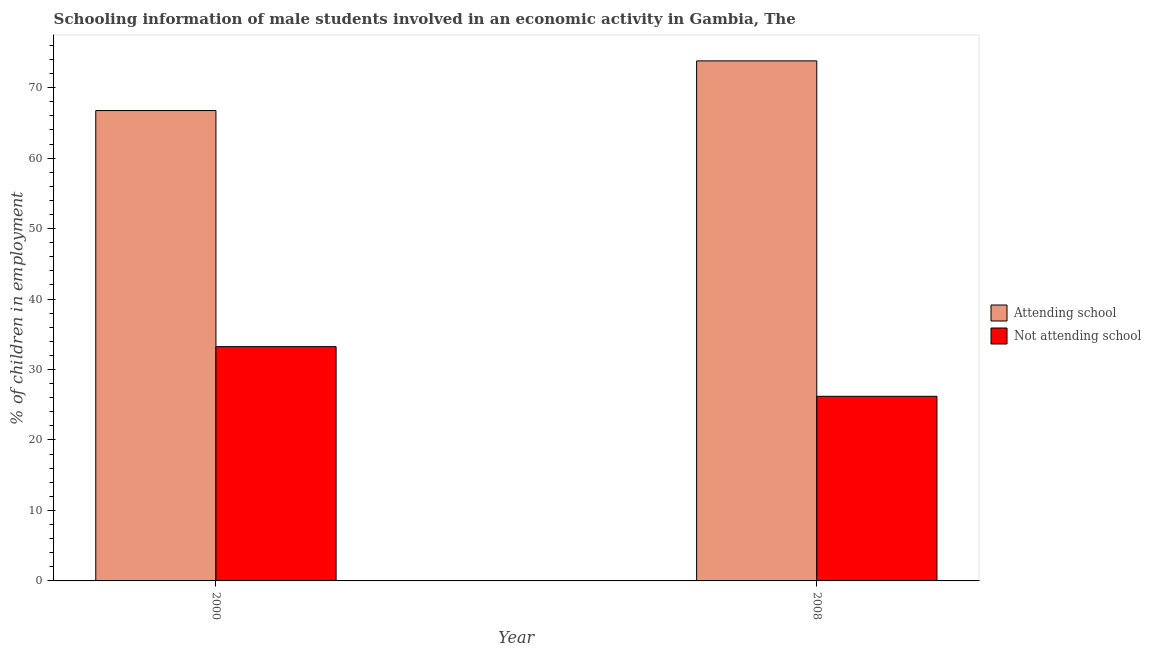How many different coloured bars are there?
Provide a short and direct response. 2. Are the number of bars per tick equal to the number of legend labels?
Your response must be concise. Yes. Are the number of bars on each tick of the X-axis equal?
Your answer should be compact. Yes. How many bars are there on the 1st tick from the left?
Make the answer very short. 2. What is the label of the 2nd group of bars from the left?
Give a very brief answer. 2008. What is the percentage of employed males who are not attending school in 2008?
Your answer should be compact. 26.2. Across all years, what is the maximum percentage of employed males who are not attending school?
Your response must be concise. 33.25. Across all years, what is the minimum percentage of employed males who are not attending school?
Provide a succinct answer. 26.2. What is the total percentage of employed males who are attending school in the graph?
Ensure brevity in your answer.  140.55. What is the difference between the percentage of employed males who are attending school in 2000 and that in 2008?
Offer a terse response. -7.05. What is the difference between the percentage of employed males who are attending school in 2008 and the percentage of employed males who are not attending school in 2000?
Ensure brevity in your answer.  7.05. What is the average percentage of employed males who are attending school per year?
Give a very brief answer. 70.28. In the year 2008, what is the difference between the percentage of employed males who are not attending school and percentage of employed males who are attending school?
Your answer should be compact. 0. In how many years, is the percentage of employed males who are not attending school greater than 54 %?
Make the answer very short. 0. What is the ratio of the percentage of employed males who are not attending school in 2000 to that in 2008?
Make the answer very short. 1.27. Is the percentage of employed males who are attending school in 2000 less than that in 2008?
Your answer should be compact. Yes. What does the 1st bar from the left in 2008 represents?
Your response must be concise. Attending school. What does the 2nd bar from the right in 2000 represents?
Keep it short and to the point. Attending school. How many bars are there?
Your answer should be very brief. 4. Does the graph contain grids?
Ensure brevity in your answer.  No. How are the legend labels stacked?
Offer a very short reply. Vertical. What is the title of the graph?
Give a very brief answer. Schooling information of male students involved in an economic activity in Gambia, The. What is the label or title of the X-axis?
Keep it short and to the point. Year. What is the label or title of the Y-axis?
Make the answer very short. % of children in employment. What is the % of children in employment of Attending school in 2000?
Your answer should be very brief. 66.75. What is the % of children in employment of Not attending school in 2000?
Give a very brief answer. 33.25. What is the % of children in employment in Attending school in 2008?
Your answer should be very brief. 73.8. What is the % of children in employment in Not attending school in 2008?
Your answer should be very brief. 26.2. Across all years, what is the maximum % of children in employment of Attending school?
Offer a terse response. 73.8. Across all years, what is the maximum % of children in employment in Not attending school?
Ensure brevity in your answer.  33.25. Across all years, what is the minimum % of children in employment in Attending school?
Make the answer very short. 66.75. Across all years, what is the minimum % of children in employment in Not attending school?
Make the answer very short. 26.2. What is the total % of children in employment of Attending school in the graph?
Make the answer very short. 140.55. What is the total % of children in employment in Not attending school in the graph?
Your answer should be very brief. 59.45. What is the difference between the % of children in employment in Attending school in 2000 and that in 2008?
Your response must be concise. -7.05. What is the difference between the % of children in employment of Not attending school in 2000 and that in 2008?
Provide a succinct answer. 7.05. What is the difference between the % of children in employment in Attending school in 2000 and the % of children in employment in Not attending school in 2008?
Your answer should be compact. 40.55. What is the average % of children in employment in Attending school per year?
Offer a terse response. 70.28. What is the average % of children in employment in Not attending school per year?
Make the answer very short. 29.72. In the year 2000, what is the difference between the % of children in employment in Attending school and % of children in employment in Not attending school?
Provide a short and direct response. 33.5. In the year 2008, what is the difference between the % of children in employment in Attending school and % of children in employment in Not attending school?
Keep it short and to the point. 47.6. What is the ratio of the % of children in employment of Attending school in 2000 to that in 2008?
Ensure brevity in your answer.  0.9. What is the ratio of the % of children in employment in Not attending school in 2000 to that in 2008?
Ensure brevity in your answer.  1.27. What is the difference between the highest and the second highest % of children in employment of Attending school?
Your answer should be compact. 7.05. What is the difference between the highest and the second highest % of children in employment in Not attending school?
Your response must be concise. 7.05. What is the difference between the highest and the lowest % of children in employment in Attending school?
Your answer should be very brief. 7.05. What is the difference between the highest and the lowest % of children in employment in Not attending school?
Provide a short and direct response. 7.05. 